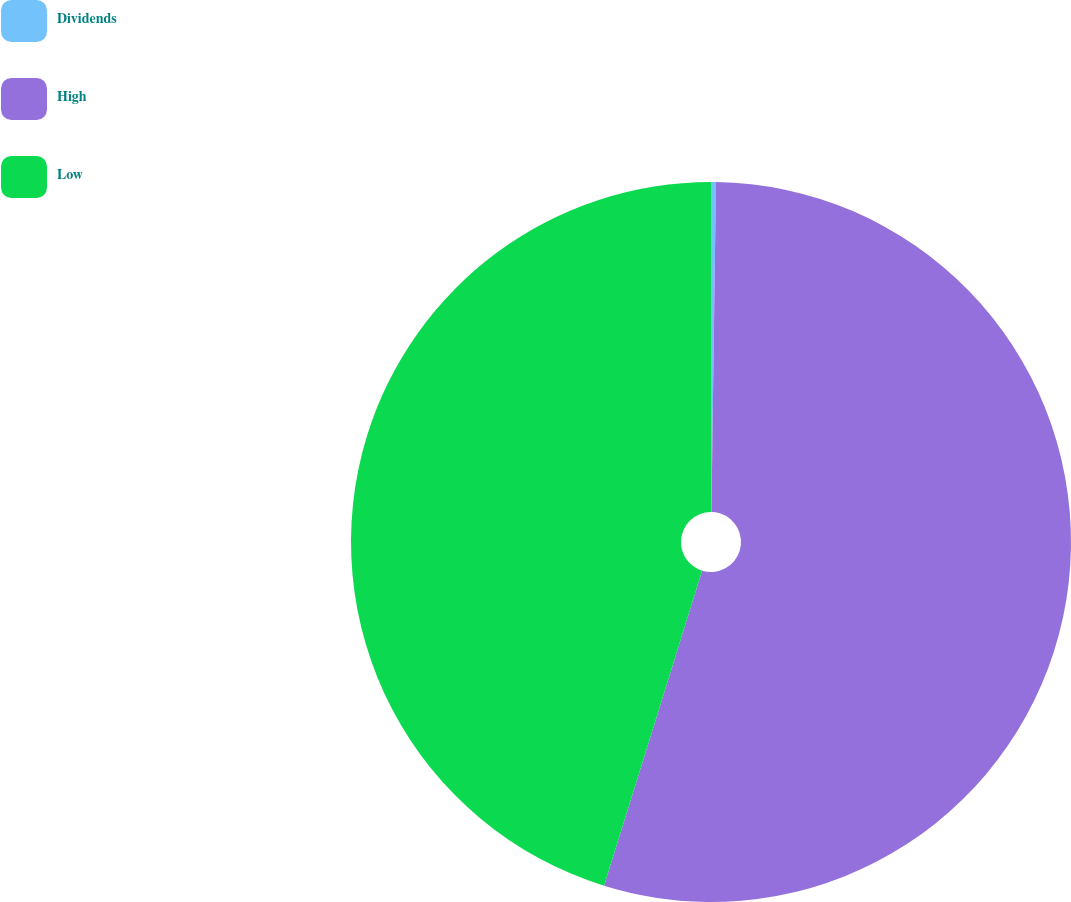Convert chart. <chart><loc_0><loc_0><loc_500><loc_500><pie_chart><fcel>Dividends<fcel>High<fcel>Low<nl><fcel>0.22%<fcel>54.58%<fcel>45.2%<nl></chart> 